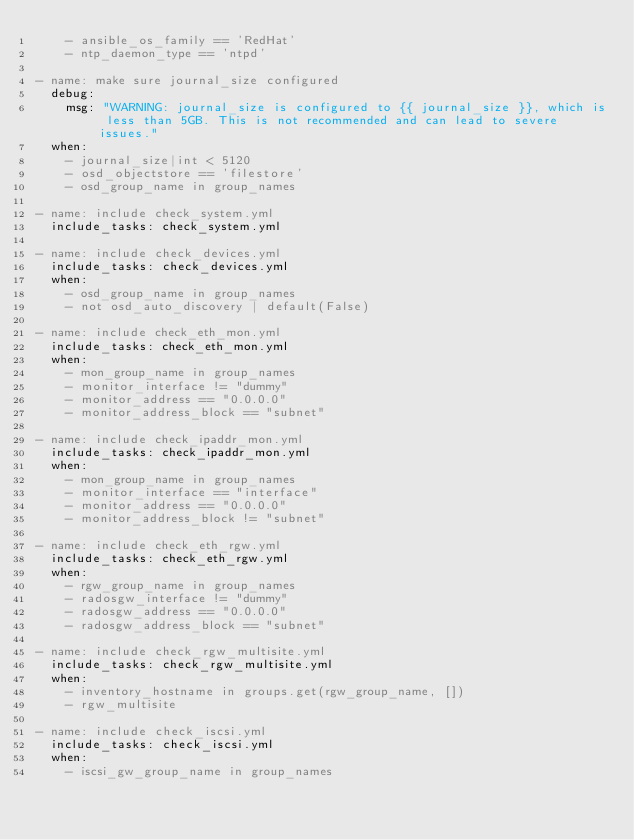<code> <loc_0><loc_0><loc_500><loc_500><_YAML_>    - ansible_os_family == 'RedHat'
    - ntp_daemon_type == 'ntpd'

- name: make sure journal_size configured
  debug:
    msg: "WARNING: journal_size is configured to {{ journal_size }}, which is less than 5GB. This is not recommended and can lead to severe issues."
  when:
    - journal_size|int < 5120
    - osd_objectstore == 'filestore'
    - osd_group_name in group_names

- name: include check_system.yml
  include_tasks: check_system.yml

- name: include check_devices.yml
  include_tasks: check_devices.yml
  when:
    - osd_group_name in group_names
    - not osd_auto_discovery | default(False)

- name: include check_eth_mon.yml
  include_tasks: check_eth_mon.yml
  when:
    - mon_group_name in group_names
    - monitor_interface != "dummy"
    - monitor_address == "0.0.0.0"
    - monitor_address_block == "subnet"

- name: include check_ipaddr_mon.yml
  include_tasks: check_ipaddr_mon.yml
  when:
    - mon_group_name in group_names
    - monitor_interface == "interface"
    - monitor_address == "0.0.0.0"
    - monitor_address_block != "subnet"

- name: include check_eth_rgw.yml
  include_tasks: check_eth_rgw.yml
  when:
    - rgw_group_name in group_names
    - radosgw_interface != "dummy"
    - radosgw_address == "0.0.0.0"
    - radosgw_address_block == "subnet"

- name: include check_rgw_multisite.yml
  include_tasks: check_rgw_multisite.yml
  when:
    - inventory_hostname in groups.get(rgw_group_name, [])
    - rgw_multisite

- name: include check_iscsi.yml
  include_tasks: check_iscsi.yml
  when:
    - iscsi_gw_group_name in group_names
</code> 